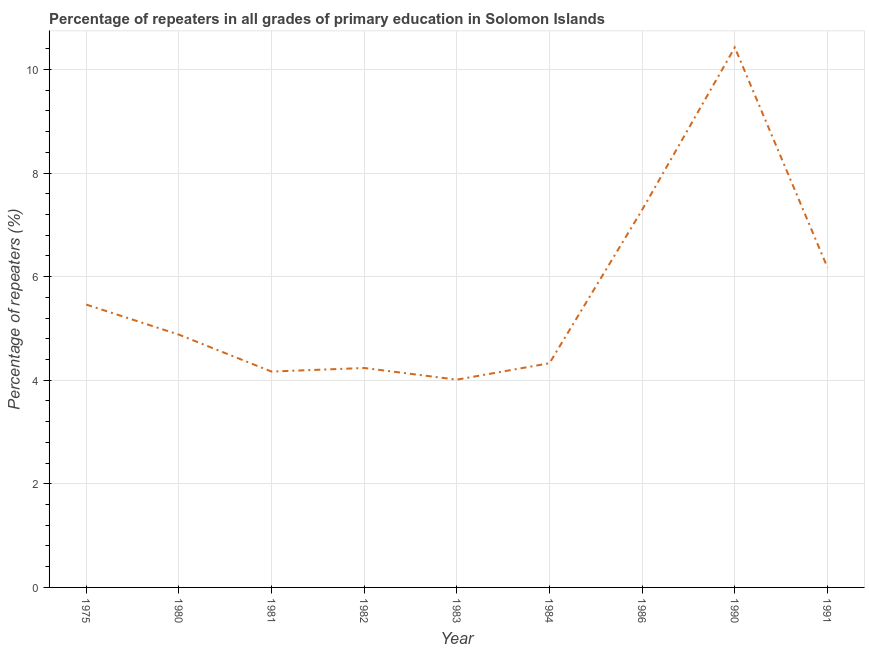What is the percentage of repeaters in primary education in 1983?
Your answer should be very brief. 4.01. Across all years, what is the maximum percentage of repeaters in primary education?
Keep it short and to the point. 10.42. Across all years, what is the minimum percentage of repeaters in primary education?
Your answer should be very brief. 4.01. In which year was the percentage of repeaters in primary education minimum?
Offer a terse response. 1983. What is the sum of the percentage of repeaters in primary education?
Provide a short and direct response. 50.98. What is the difference between the percentage of repeaters in primary education in 1980 and 1982?
Keep it short and to the point. 0.64. What is the average percentage of repeaters in primary education per year?
Make the answer very short. 5.66. What is the median percentage of repeaters in primary education?
Your answer should be very brief. 4.88. In how many years, is the percentage of repeaters in primary education greater than 3.2 %?
Your response must be concise. 9. Do a majority of the years between 1975 and 1981 (inclusive) have percentage of repeaters in primary education greater than 0.8 %?
Your response must be concise. Yes. What is the ratio of the percentage of repeaters in primary education in 1981 to that in 1991?
Keep it short and to the point. 0.67. Is the difference between the percentage of repeaters in primary education in 1984 and 1990 greater than the difference between any two years?
Provide a short and direct response. No. What is the difference between the highest and the second highest percentage of repeaters in primary education?
Give a very brief answer. 3.14. What is the difference between the highest and the lowest percentage of repeaters in primary education?
Your answer should be compact. 6.41. In how many years, is the percentage of repeaters in primary education greater than the average percentage of repeaters in primary education taken over all years?
Offer a terse response. 3. How many years are there in the graph?
Provide a short and direct response. 9. What is the difference between two consecutive major ticks on the Y-axis?
Provide a succinct answer. 2. Are the values on the major ticks of Y-axis written in scientific E-notation?
Give a very brief answer. No. Does the graph contain any zero values?
Keep it short and to the point. No. Does the graph contain grids?
Keep it short and to the point. Yes. What is the title of the graph?
Your answer should be compact. Percentage of repeaters in all grades of primary education in Solomon Islands. What is the label or title of the X-axis?
Offer a very short reply. Year. What is the label or title of the Y-axis?
Your answer should be compact. Percentage of repeaters (%). What is the Percentage of repeaters (%) of 1975?
Ensure brevity in your answer.  5.46. What is the Percentage of repeaters (%) in 1980?
Your answer should be compact. 4.88. What is the Percentage of repeaters (%) of 1981?
Ensure brevity in your answer.  4.17. What is the Percentage of repeaters (%) of 1982?
Provide a succinct answer. 4.24. What is the Percentage of repeaters (%) of 1983?
Your answer should be very brief. 4.01. What is the Percentage of repeaters (%) of 1984?
Ensure brevity in your answer.  4.33. What is the Percentage of repeaters (%) of 1986?
Your answer should be compact. 7.29. What is the Percentage of repeaters (%) in 1990?
Give a very brief answer. 10.42. What is the Percentage of repeaters (%) of 1991?
Keep it short and to the point. 6.18. What is the difference between the Percentage of repeaters (%) in 1975 and 1980?
Offer a terse response. 0.58. What is the difference between the Percentage of repeaters (%) in 1975 and 1981?
Keep it short and to the point. 1.29. What is the difference between the Percentage of repeaters (%) in 1975 and 1982?
Ensure brevity in your answer.  1.22. What is the difference between the Percentage of repeaters (%) in 1975 and 1983?
Offer a terse response. 1.45. What is the difference between the Percentage of repeaters (%) in 1975 and 1984?
Your answer should be compact. 1.13. What is the difference between the Percentage of repeaters (%) in 1975 and 1986?
Your answer should be compact. -1.83. What is the difference between the Percentage of repeaters (%) in 1975 and 1990?
Give a very brief answer. -4.96. What is the difference between the Percentage of repeaters (%) in 1975 and 1991?
Give a very brief answer. -0.72. What is the difference between the Percentage of repeaters (%) in 1980 and 1981?
Offer a very short reply. 0.71. What is the difference between the Percentage of repeaters (%) in 1980 and 1982?
Offer a terse response. 0.64. What is the difference between the Percentage of repeaters (%) in 1980 and 1983?
Offer a very short reply. 0.87. What is the difference between the Percentage of repeaters (%) in 1980 and 1984?
Provide a short and direct response. 0.55. What is the difference between the Percentage of repeaters (%) in 1980 and 1986?
Provide a short and direct response. -2.41. What is the difference between the Percentage of repeaters (%) in 1980 and 1990?
Provide a short and direct response. -5.54. What is the difference between the Percentage of repeaters (%) in 1980 and 1991?
Offer a terse response. -1.3. What is the difference between the Percentage of repeaters (%) in 1981 and 1982?
Give a very brief answer. -0.07. What is the difference between the Percentage of repeaters (%) in 1981 and 1983?
Offer a very short reply. 0.16. What is the difference between the Percentage of repeaters (%) in 1981 and 1984?
Your answer should be compact. -0.16. What is the difference between the Percentage of repeaters (%) in 1981 and 1986?
Offer a very short reply. -3.12. What is the difference between the Percentage of repeaters (%) in 1981 and 1990?
Provide a succinct answer. -6.26. What is the difference between the Percentage of repeaters (%) in 1981 and 1991?
Ensure brevity in your answer.  -2.01. What is the difference between the Percentage of repeaters (%) in 1982 and 1983?
Offer a terse response. 0.23. What is the difference between the Percentage of repeaters (%) in 1982 and 1984?
Provide a succinct answer. -0.09. What is the difference between the Percentage of repeaters (%) in 1982 and 1986?
Ensure brevity in your answer.  -3.05. What is the difference between the Percentage of repeaters (%) in 1982 and 1990?
Make the answer very short. -6.19. What is the difference between the Percentage of repeaters (%) in 1982 and 1991?
Offer a very short reply. -1.94. What is the difference between the Percentage of repeaters (%) in 1983 and 1984?
Make the answer very short. -0.32. What is the difference between the Percentage of repeaters (%) in 1983 and 1986?
Your answer should be very brief. -3.28. What is the difference between the Percentage of repeaters (%) in 1983 and 1990?
Provide a succinct answer. -6.41. What is the difference between the Percentage of repeaters (%) in 1983 and 1991?
Ensure brevity in your answer.  -2.17. What is the difference between the Percentage of repeaters (%) in 1984 and 1986?
Provide a short and direct response. -2.96. What is the difference between the Percentage of repeaters (%) in 1984 and 1990?
Make the answer very short. -6.1. What is the difference between the Percentage of repeaters (%) in 1984 and 1991?
Provide a short and direct response. -1.85. What is the difference between the Percentage of repeaters (%) in 1986 and 1990?
Your answer should be very brief. -3.14. What is the difference between the Percentage of repeaters (%) in 1986 and 1991?
Your answer should be very brief. 1.11. What is the difference between the Percentage of repeaters (%) in 1990 and 1991?
Offer a very short reply. 4.25. What is the ratio of the Percentage of repeaters (%) in 1975 to that in 1980?
Ensure brevity in your answer.  1.12. What is the ratio of the Percentage of repeaters (%) in 1975 to that in 1981?
Offer a terse response. 1.31. What is the ratio of the Percentage of repeaters (%) in 1975 to that in 1982?
Your answer should be compact. 1.29. What is the ratio of the Percentage of repeaters (%) in 1975 to that in 1983?
Offer a terse response. 1.36. What is the ratio of the Percentage of repeaters (%) in 1975 to that in 1984?
Your response must be concise. 1.26. What is the ratio of the Percentage of repeaters (%) in 1975 to that in 1986?
Offer a very short reply. 0.75. What is the ratio of the Percentage of repeaters (%) in 1975 to that in 1990?
Keep it short and to the point. 0.52. What is the ratio of the Percentage of repeaters (%) in 1975 to that in 1991?
Your answer should be very brief. 0.88. What is the ratio of the Percentage of repeaters (%) in 1980 to that in 1981?
Your answer should be compact. 1.17. What is the ratio of the Percentage of repeaters (%) in 1980 to that in 1982?
Make the answer very short. 1.15. What is the ratio of the Percentage of repeaters (%) in 1980 to that in 1983?
Ensure brevity in your answer.  1.22. What is the ratio of the Percentage of repeaters (%) in 1980 to that in 1984?
Provide a short and direct response. 1.13. What is the ratio of the Percentage of repeaters (%) in 1980 to that in 1986?
Your answer should be compact. 0.67. What is the ratio of the Percentage of repeaters (%) in 1980 to that in 1990?
Ensure brevity in your answer.  0.47. What is the ratio of the Percentage of repeaters (%) in 1980 to that in 1991?
Give a very brief answer. 0.79. What is the ratio of the Percentage of repeaters (%) in 1981 to that in 1983?
Make the answer very short. 1.04. What is the ratio of the Percentage of repeaters (%) in 1981 to that in 1984?
Offer a terse response. 0.96. What is the ratio of the Percentage of repeaters (%) in 1981 to that in 1986?
Keep it short and to the point. 0.57. What is the ratio of the Percentage of repeaters (%) in 1981 to that in 1991?
Give a very brief answer. 0.68. What is the ratio of the Percentage of repeaters (%) in 1982 to that in 1983?
Your answer should be compact. 1.06. What is the ratio of the Percentage of repeaters (%) in 1982 to that in 1984?
Your response must be concise. 0.98. What is the ratio of the Percentage of repeaters (%) in 1982 to that in 1986?
Your answer should be compact. 0.58. What is the ratio of the Percentage of repeaters (%) in 1982 to that in 1990?
Give a very brief answer. 0.41. What is the ratio of the Percentage of repeaters (%) in 1982 to that in 1991?
Give a very brief answer. 0.69. What is the ratio of the Percentage of repeaters (%) in 1983 to that in 1984?
Ensure brevity in your answer.  0.93. What is the ratio of the Percentage of repeaters (%) in 1983 to that in 1986?
Keep it short and to the point. 0.55. What is the ratio of the Percentage of repeaters (%) in 1983 to that in 1990?
Offer a very short reply. 0.39. What is the ratio of the Percentage of repeaters (%) in 1983 to that in 1991?
Your answer should be very brief. 0.65. What is the ratio of the Percentage of repeaters (%) in 1984 to that in 1986?
Provide a short and direct response. 0.59. What is the ratio of the Percentage of repeaters (%) in 1984 to that in 1990?
Give a very brief answer. 0.41. What is the ratio of the Percentage of repeaters (%) in 1984 to that in 1991?
Your answer should be compact. 0.7. What is the ratio of the Percentage of repeaters (%) in 1986 to that in 1990?
Keep it short and to the point. 0.7. What is the ratio of the Percentage of repeaters (%) in 1986 to that in 1991?
Provide a short and direct response. 1.18. What is the ratio of the Percentage of repeaters (%) in 1990 to that in 1991?
Your response must be concise. 1.69. 